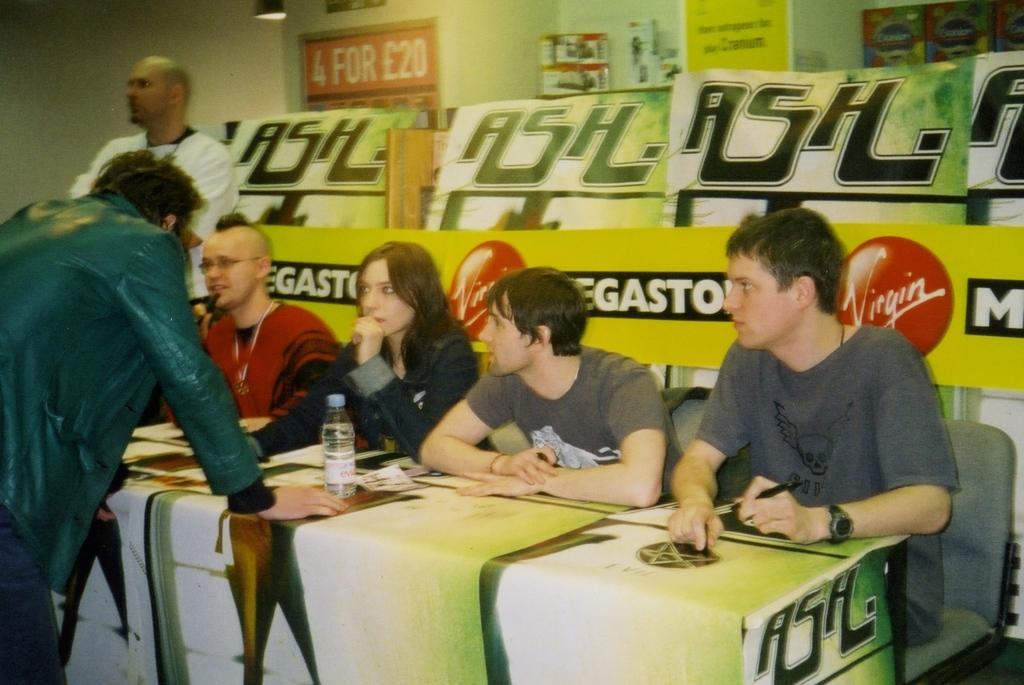Could you give a brief overview of what you see in this image? In this image i can see there are the four persons sitting on the chairs in front a table on the table there is a bottle and in front of them there is a person standing and wearing a gray color jacket and back side of them there is a light on the middle corner. 